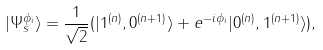<formula> <loc_0><loc_0><loc_500><loc_500>| \Psi _ { s } ^ { \phi _ { i } } \rangle = \frac { 1 } { \sqrt { 2 } } ( | 1 ^ { ( n ) } , 0 ^ { ( n + 1 ) } \rangle + e ^ { - i \phi _ { i } } | 0 ^ { ( n ) } , 1 ^ { ( n + 1 ) } \rangle ) ,</formula> 